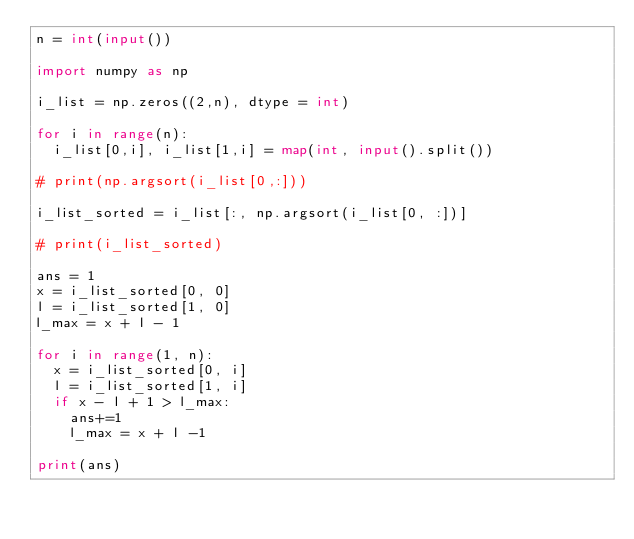Convert code to text. <code><loc_0><loc_0><loc_500><loc_500><_Python_>n = int(input())

import numpy as np

i_list = np.zeros((2,n), dtype = int)

for i in range(n):
  i_list[0,i], i_list[1,i] = map(int, input().split())

# print(np.argsort(i_list[0,:]))

i_list_sorted = i_list[:, np.argsort(i_list[0, :])]

# print(i_list_sorted)

ans = 1
x = i_list_sorted[0, 0]
l = i_list_sorted[1, 0]
l_max = x + l - 1

for i in range(1, n):
  x = i_list_sorted[0, i]
  l = i_list_sorted[1, i]
  if x - l + 1 > l_max:
    ans+=1
    l_max = x + l -1
 
print(ans)</code> 